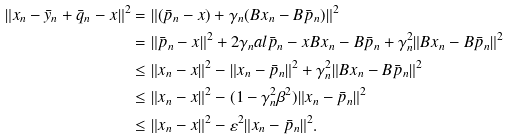Convert formula to latex. <formula><loc_0><loc_0><loc_500><loc_500>\| x _ { n } - \bar { y } _ { n } + \bar { q } _ { n } - x \| ^ { 2 } & = \| ( \bar { p } _ { n } - x ) + \gamma _ { n } ( B x _ { n } - B \bar { p } _ { n } ) \| ^ { 2 } \\ & = \| \bar { p } _ { n } - x \| ^ { 2 } + 2 \gamma _ { n } a l { \bar { p } _ { n } - x } { B x _ { n } - B \bar { p } _ { n } } + \gamma _ { n } ^ { 2 } \| B x _ { n } - B \bar { p } _ { n } \| ^ { 2 } \\ & \leq \| x _ { n } - x \| ^ { 2 } - \| x _ { n } - \bar { p } _ { n } \| ^ { 2 } + \gamma _ { n } ^ { 2 } \| B x _ { n } - B \bar { p } _ { n } \| ^ { 2 } \\ & \leq \| x _ { n } - x \| ^ { 2 } - ( 1 - \gamma _ { n } ^ { 2 } \beta ^ { 2 } ) \| x _ { n } - \bar { p } _ { n } \| ^ { 2 } \\ & \leq \| x _ { n } - x \| ^ { 2 } - \varepsilon ^ { 2 } \| x _ { n } - \bar { p } _ { n } \| ^ { 2 } .</formula> 